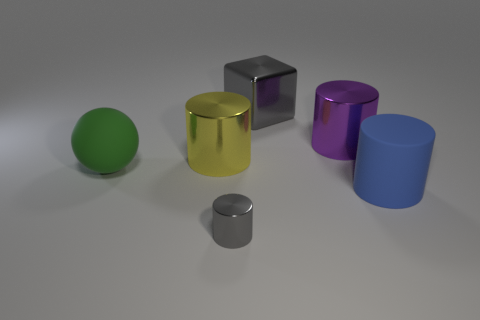Subtract 1 cylinders. How many cylinders are left? 3 Add 2 purple cylinders. How many objects exist? 8 Subtract all cylinders. How many objects are left? 2 Add 3 tiny blue rubber objects. How many tiny blue rubber objects exist? 3 Subtract 0 cyan cylinders. How many objects are left? 6 Subtract all big purple things. Subtract all tiny rubber spheres. How many objects are left? 5 Add 6 yellow shiny cylinders. How many yellow shiny cylinders are left? 7 